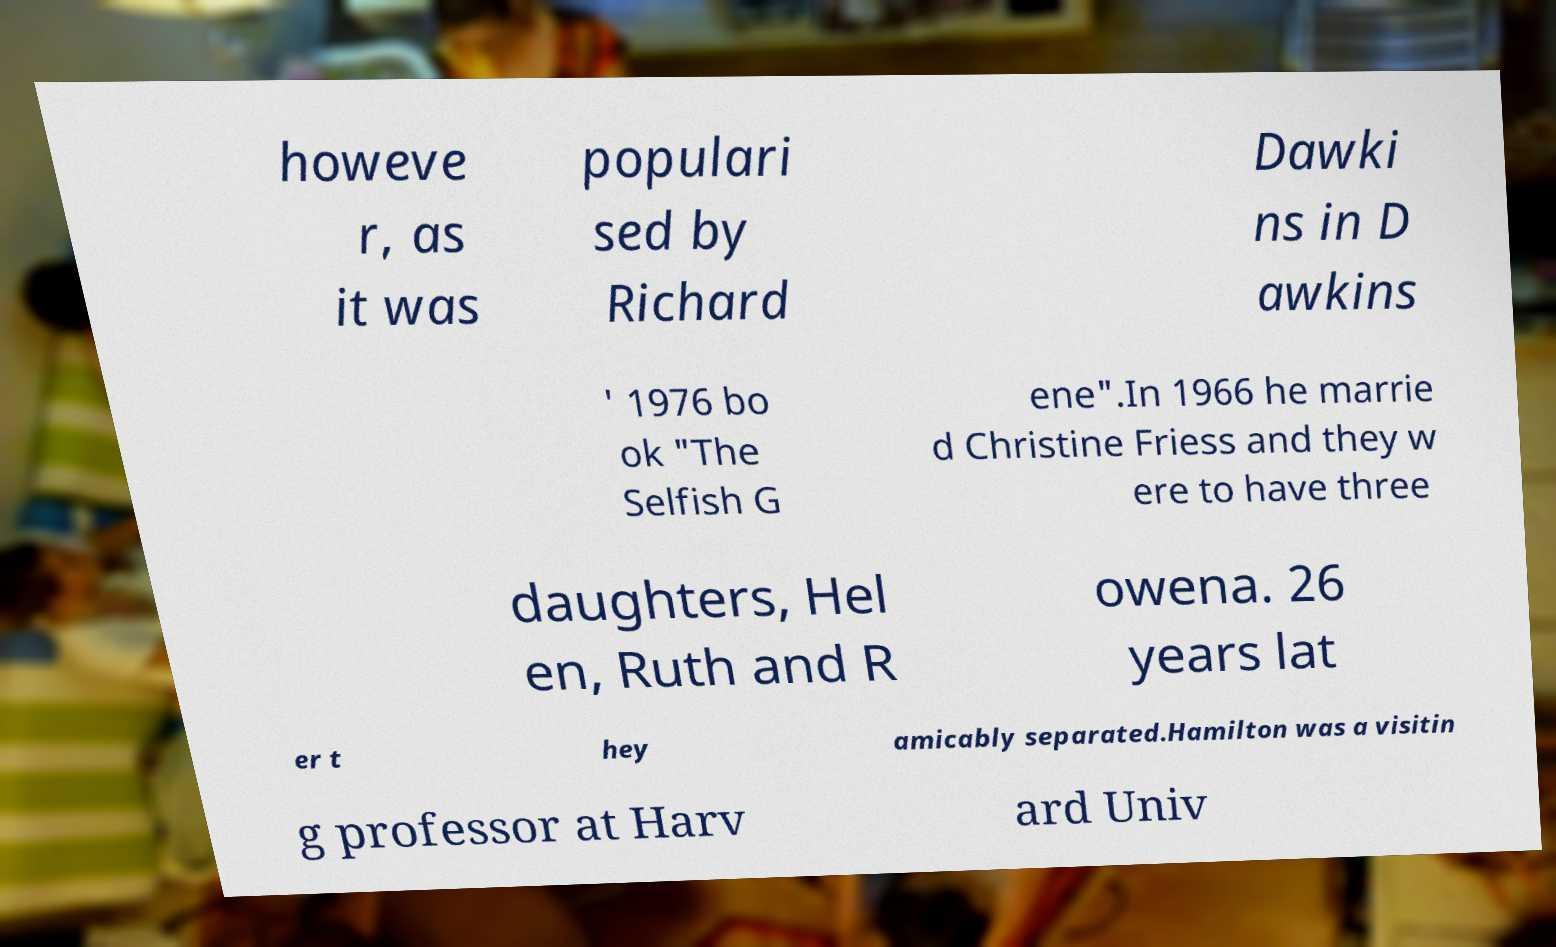What messages or text are displayed in this image? I need them in a readable, typed format. howeve r, as it was populari sed by Richard Dawki ns in D awkins ' 1976 bo ok "The Selfish G ene".In 1966 he marrie d Christine Friess and they w ere to have three daughters, Hel en, Ruth and R owena. 26 years lat er t hey amicably separated.Hamilton was a visitin g professor at Harv ard Univ 